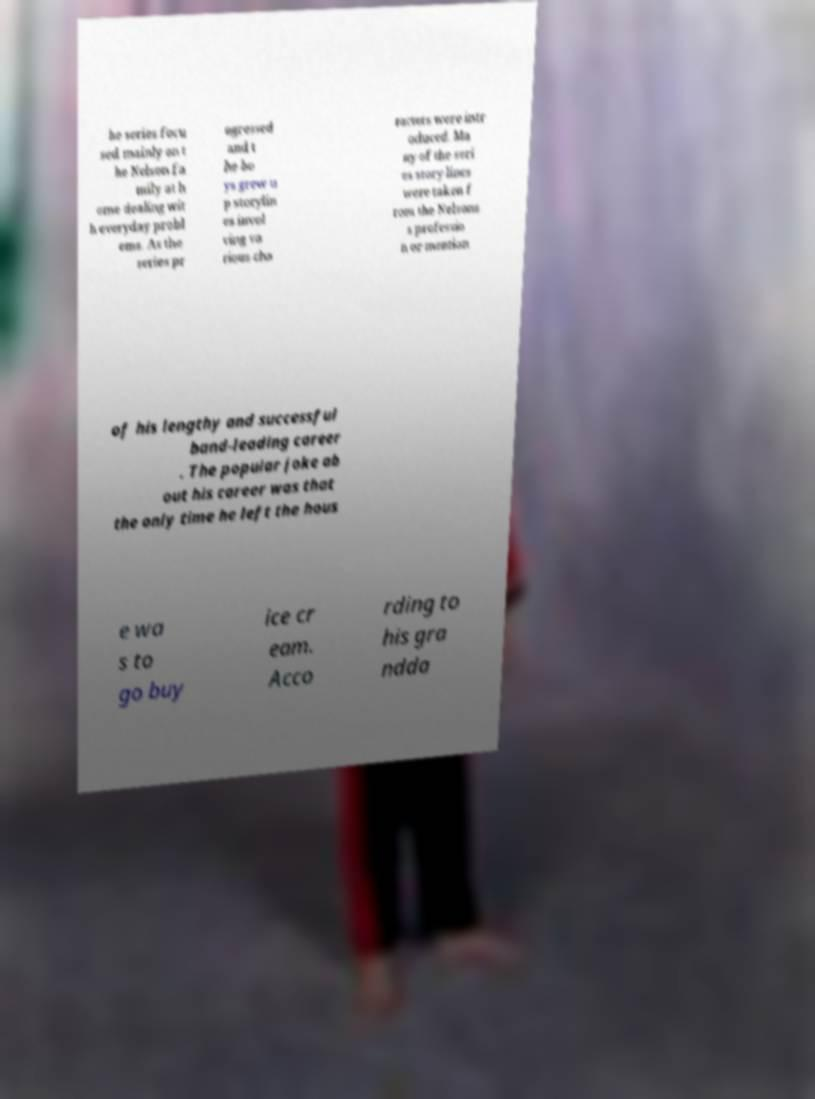Please read and relay the text visible in this image. What does it say? he series focu sed mainly on t he Nelson fa mily at h ome dealing wit h everyday probl ems. As the series pr ogressed and t he bo ys grew u p storylin es invol ving va rious cha racters were intr oduced. Ma ny of the seri es story lines were taken f rom the Nelsons s professio n or mention of his lengthy and successful band-leading career . The popular joke ab out his career was that the only time he left the hous e wa s to go buy ice cr eam. Acco rding to his gra ndda 